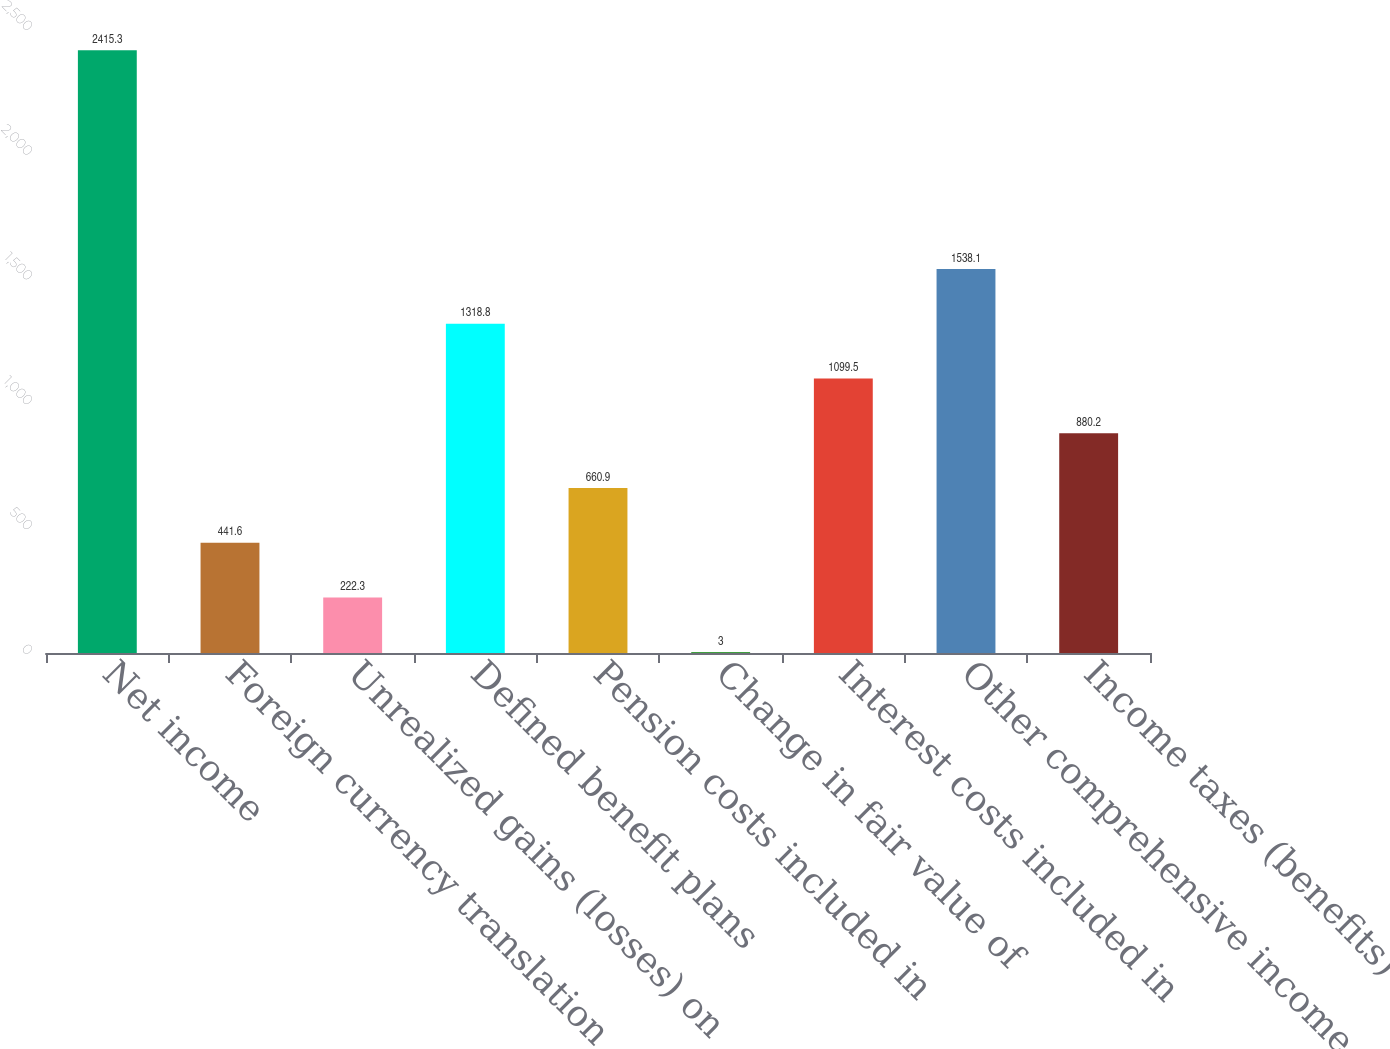<chart> <loc_0><loc_0><loc_500><loc_500><bar_chart><fcel>Net income<fcel>Foreign currency translation<fcel>Unrealized gains (losses) on<fcel>Defined benefit plans<fcel>Pension costs included in<fcel>Change in fair value of<fcel>Interest costs included in<fcel>Other comprehensive income<fcel>Income taxes (benefits)<nl><fcel>2415.3<fcel>441.6<fcel>222.3<fcel>1318.8<fcel>660.9<fcel>3<fcel>1099.5<fcel>1538.1<fcel>880.2<nl></chart> 